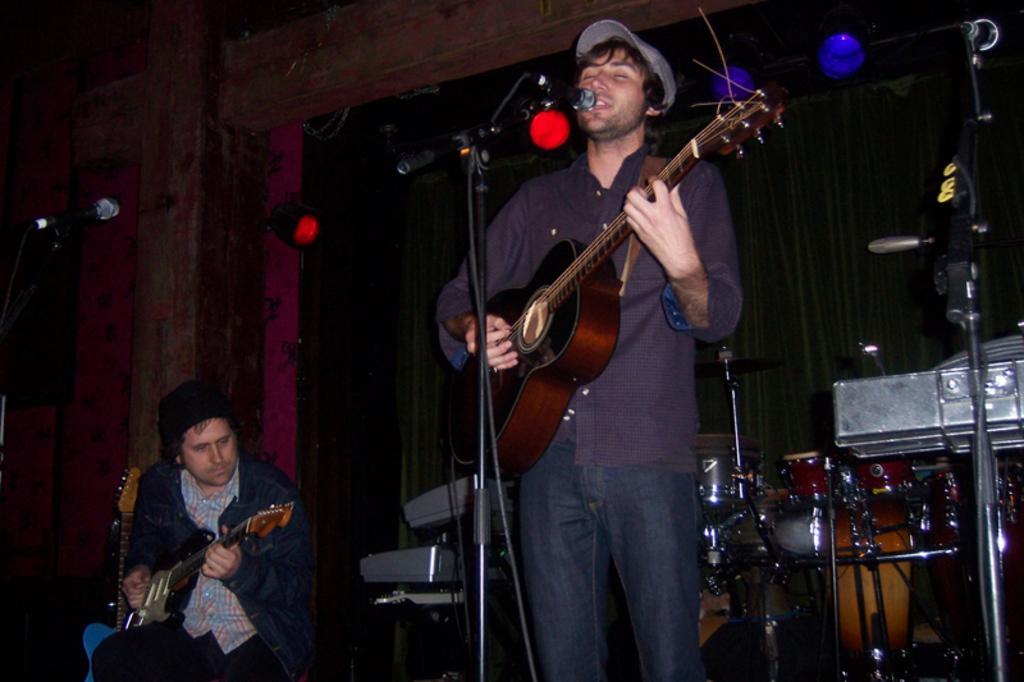Could you give a brief overview of what you see in this image? there are two persons one person is sitting and playing guitar and another person is standing in front of a micro phone and playing guitar 